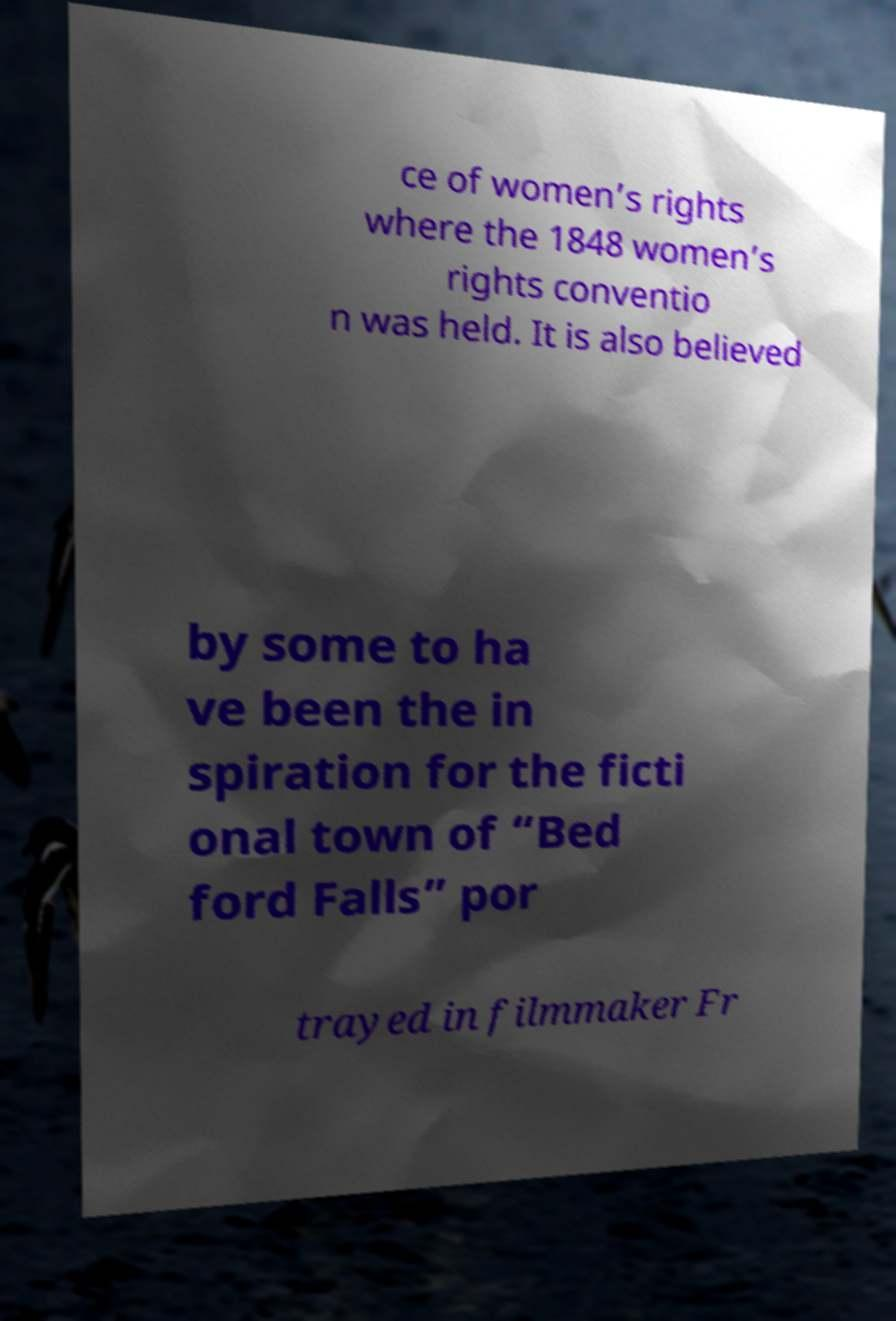Could you assist in decoding the text presented in this image and type it out clearly? ce of women’s rights where the 1848 women’s rights conventio n was held. It is also believed by some to ha ve been the in spiration for the ficti onal town of “Bed ford Falls” por trayed in filmmaker Fr 